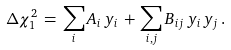<formula> <loc_0><loc_0><loc_500><loc_500>\Delta \chi _ { 1 } ^ { 2 } \, = \, \sum _ { i } A _ { i } \, y _ { i } \, + \, \sum _ { i , j } B _ { i j } \, y _ { i } \, y _ { j } \, .</formula> 